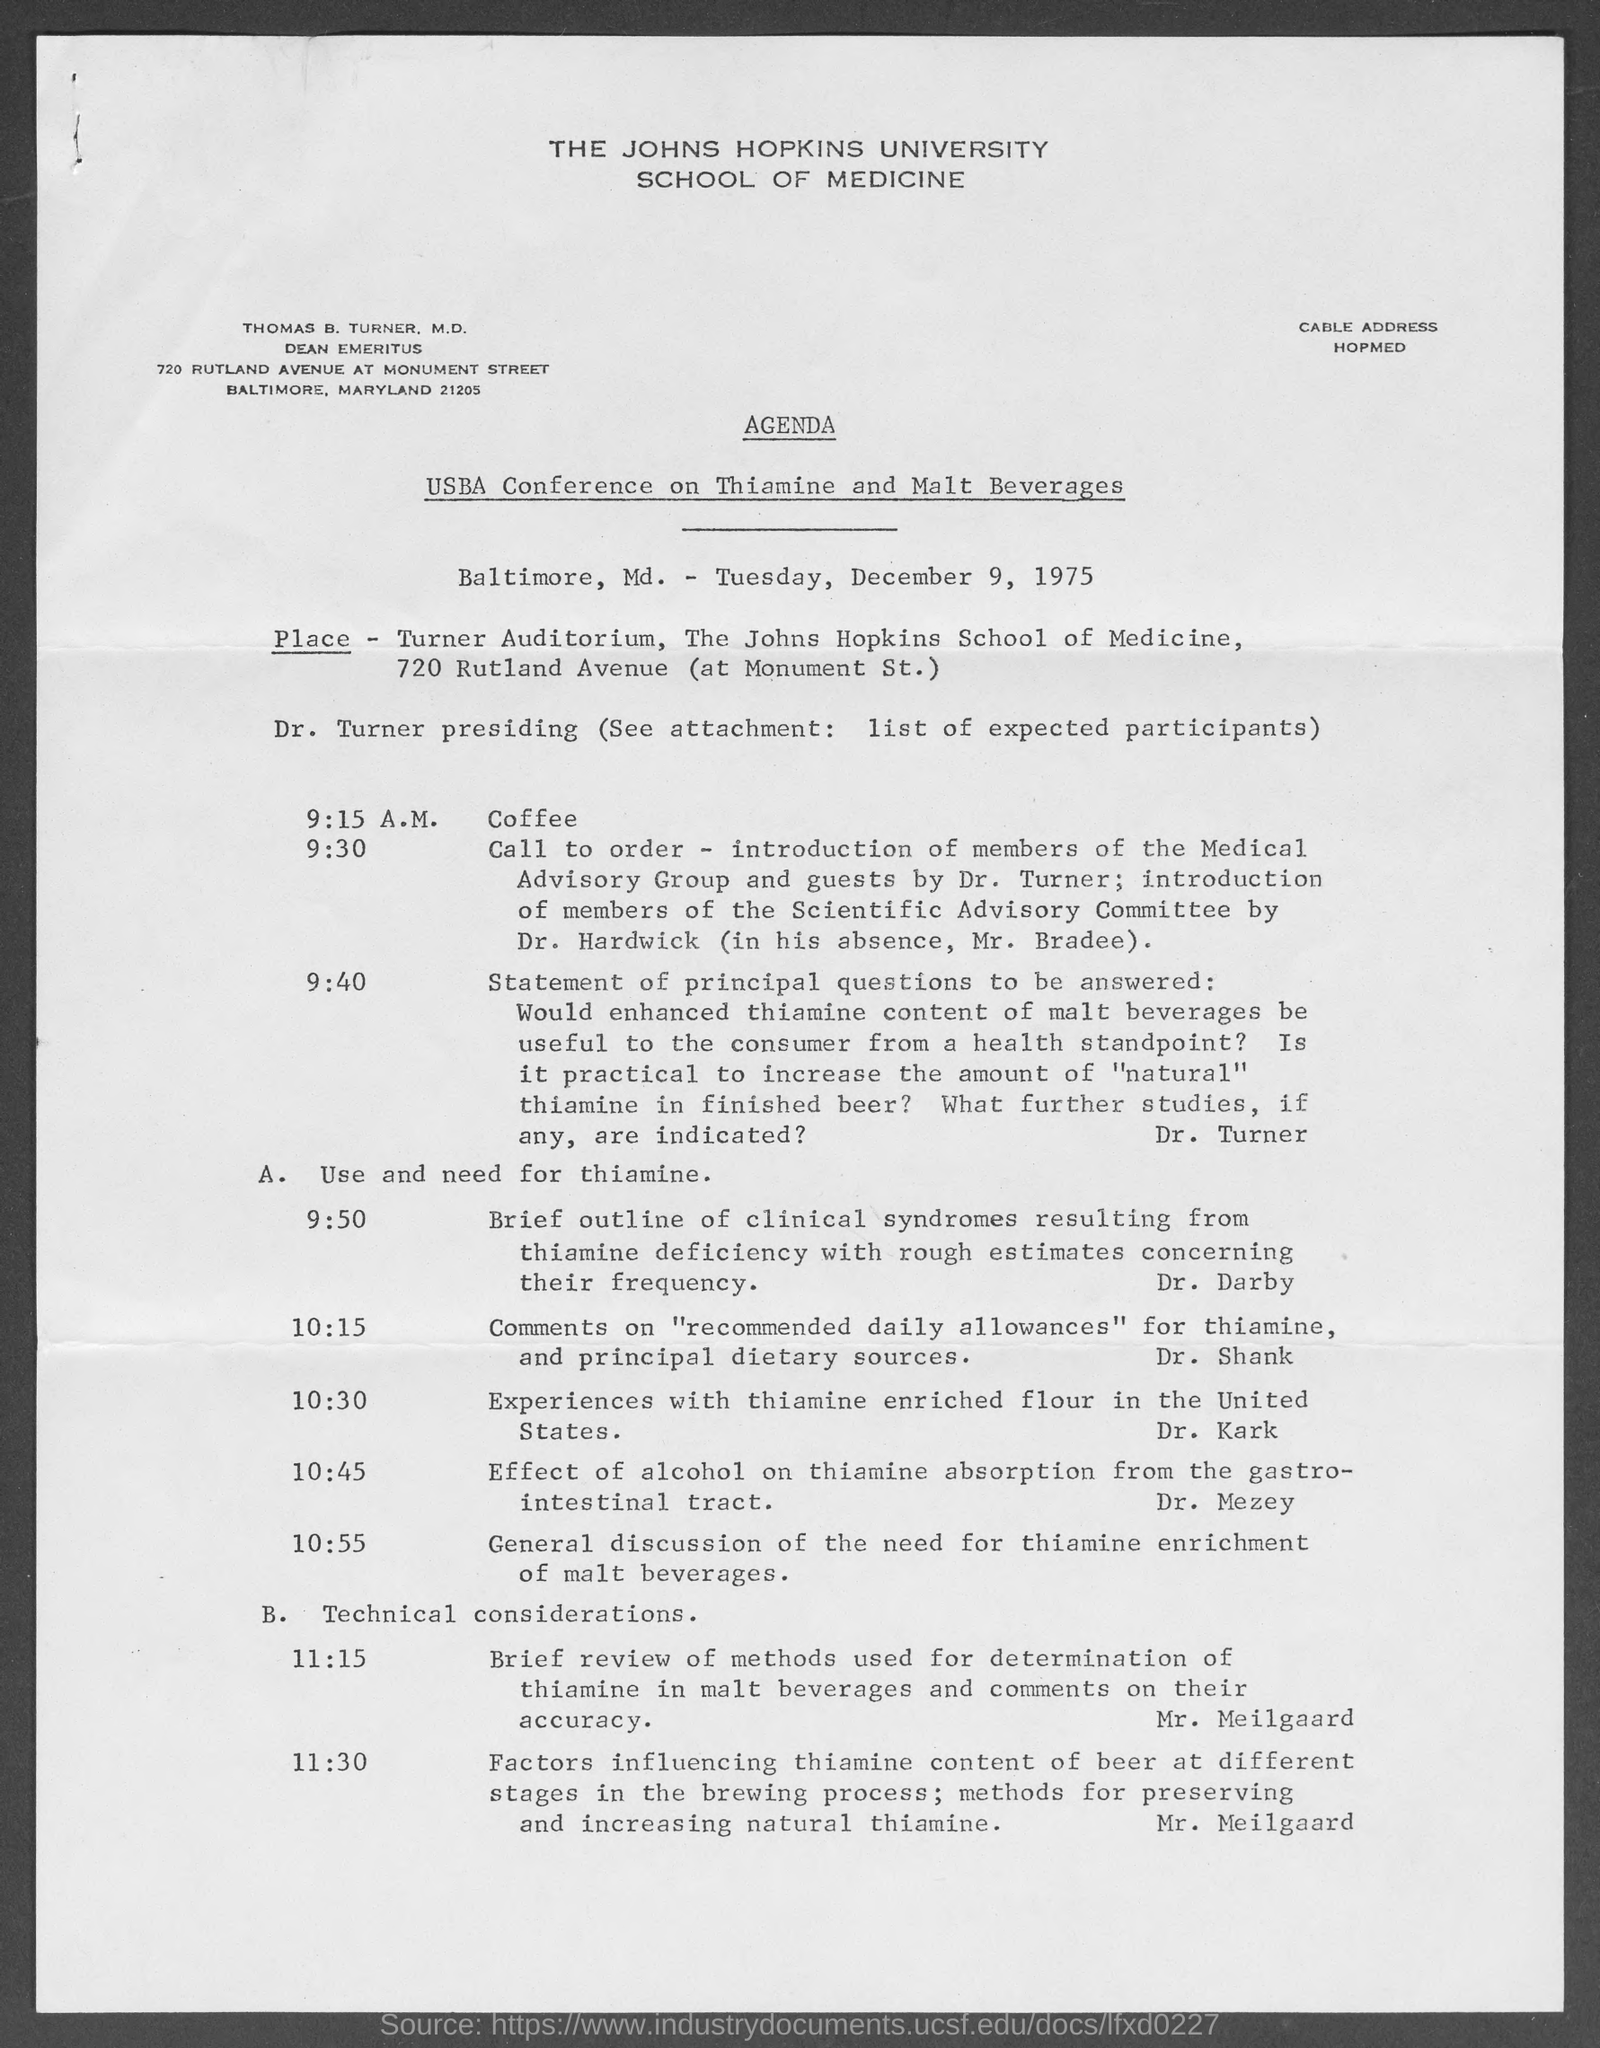Highlight a few significant elements in this photo. The USBA conference focuses on the topics of thiamine and malt beverages. It is mentioned in the agenda that coffee will be served at 9:15 A.M. The document mentions Tuesday as the day of the week. The John Hopkins University is named at the top of the page. The call to order in the agenda is scheduled for 9:30. 